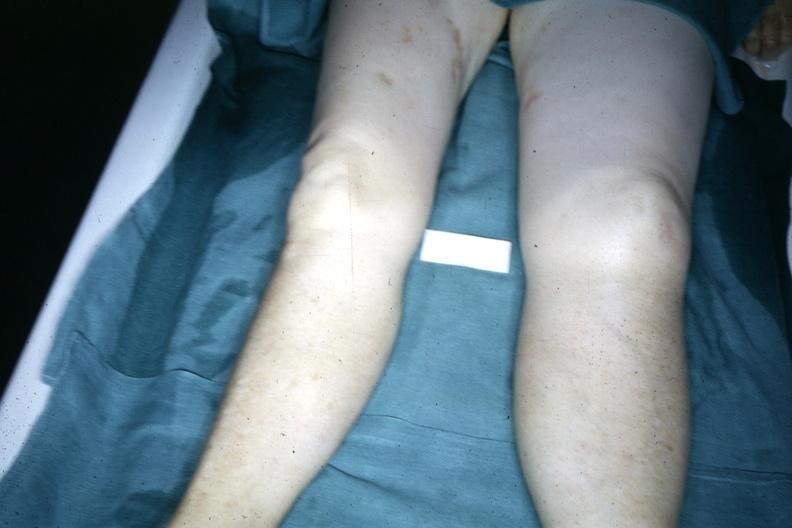what is both legs demonstrated?
Answer the question using a single word or phrase. With one about twice the size of the other due to malignant lymphoma involving lymphatic drainage 